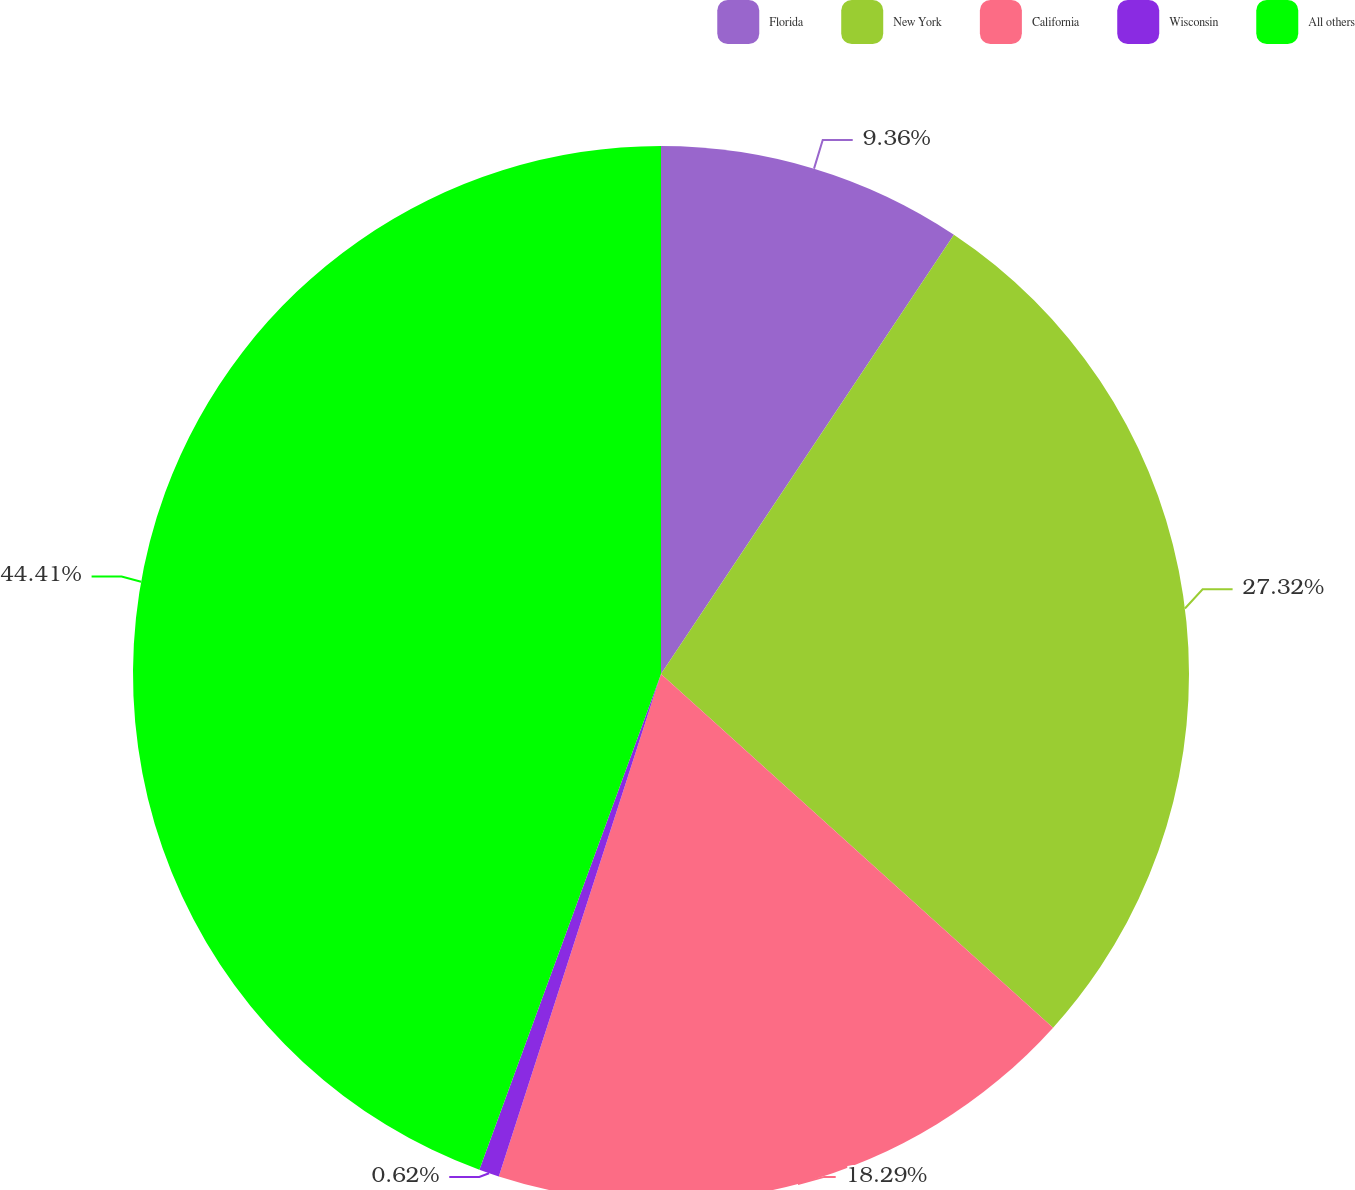Convert chart. <chart><loc_0><loc_0><loc_500><loc_500><pie_chart><fcel>Florida<fcel>New York<fcel>California<fcel>Wisconsin<fcel>All others<nl><fcel>9.36%<fcel>27.32%<fcel>18.29%<fcel>0.62%<fcel>44.41%<nl></chart> 